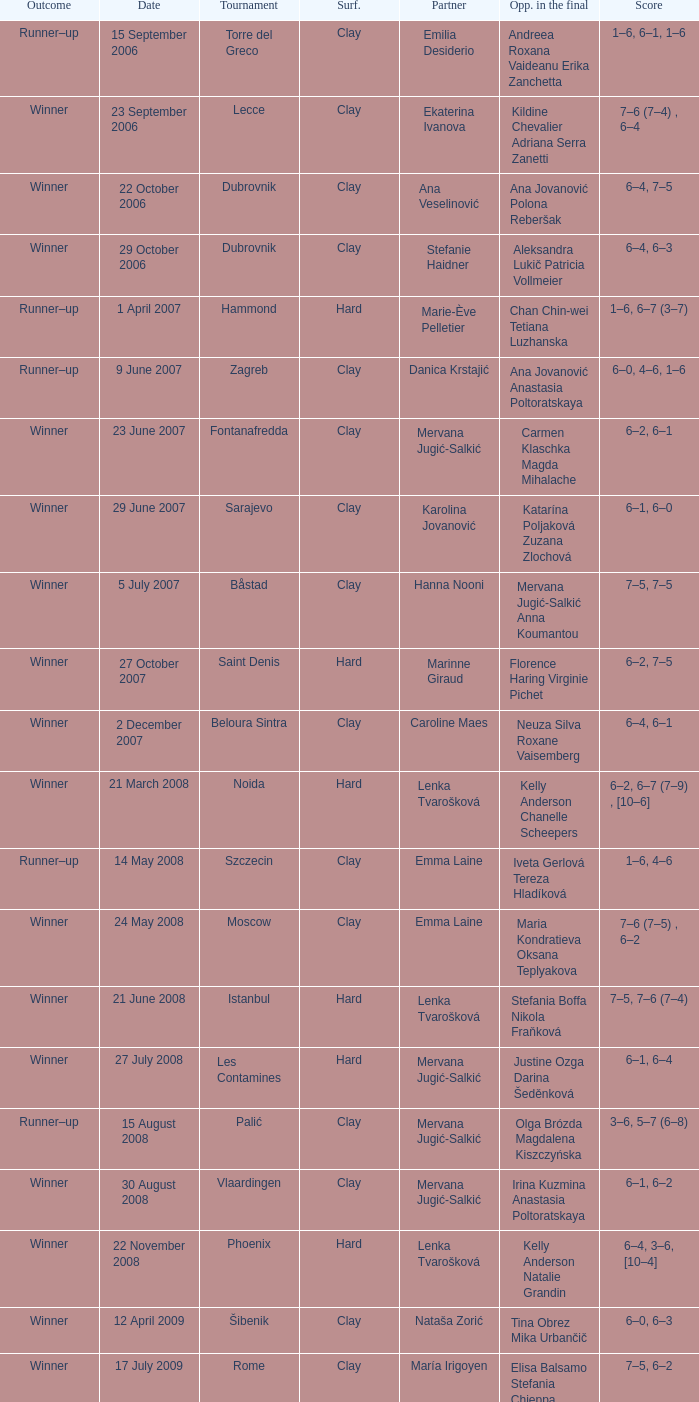Who were the opponents in the final at Noida? Kelly Anderson Chanelle Scheepers. 